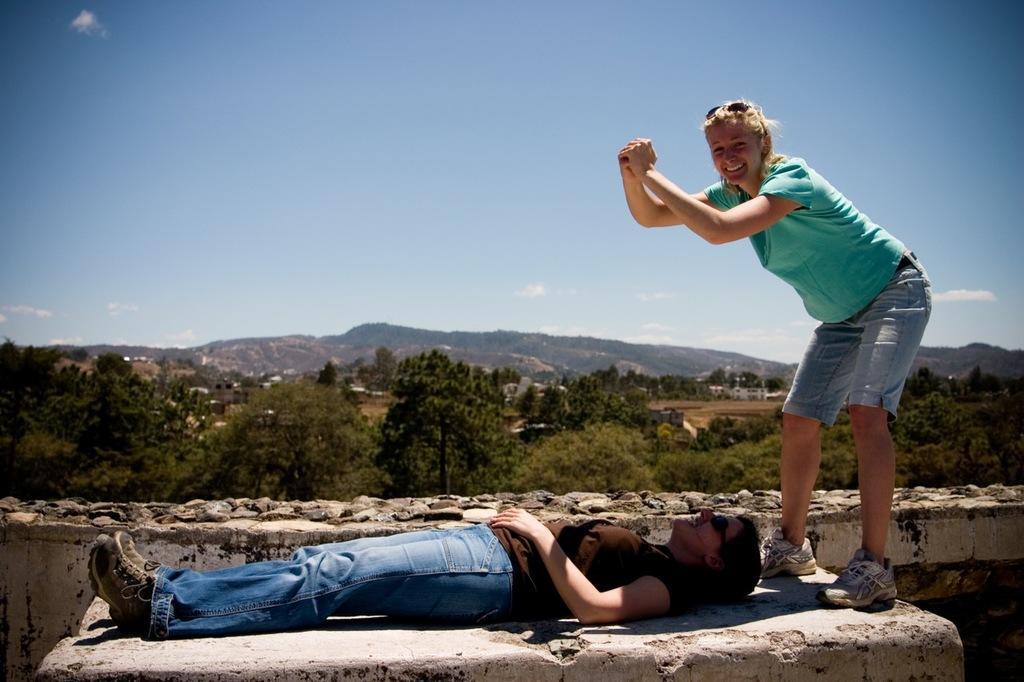Describe this image in one or two sentences. To the right side of the image there is a lady. At the bottom of the image there is a lady lying on the surface. In the background of the image there are mountains, trees. At the top of the image there is sky. 